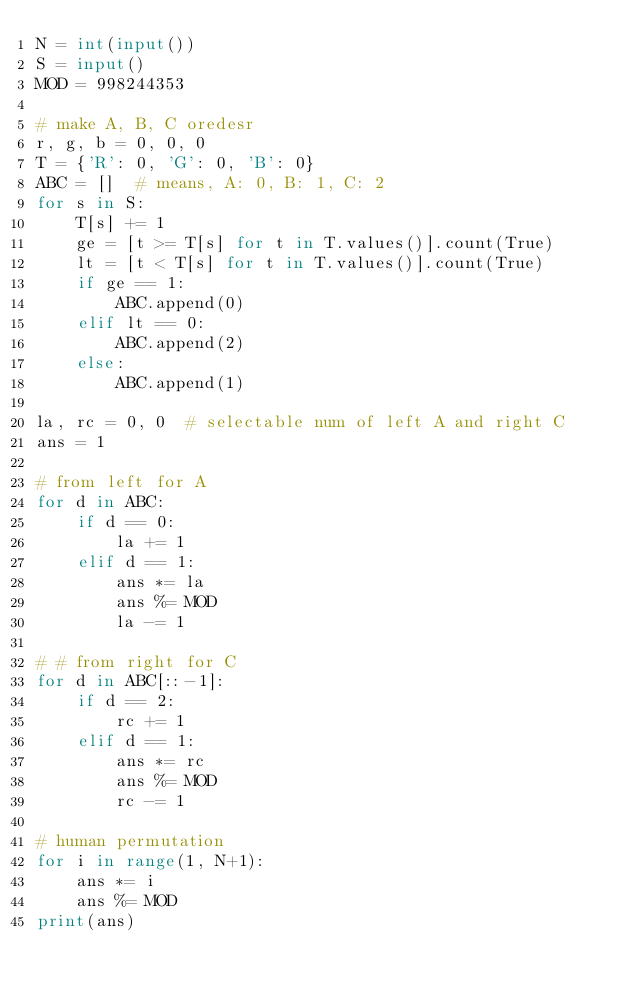Convert code to text. <code><loc_0><loc_0><loc_500><loc_500><_Python_>N = int(input())
S = input()
MOD = 998244353

# make A, B, C oredesr
r, g, b = 0, 0, 0
T = {'R': 0, 'G': 0, 'B': 0}
ABC = []  # means, A: 0, B: 1, C: 2
for s in S:
    T[s] += 1
    ge = [t >= T[s] for t in T.values()].count(True)
    lt = [t < T[s] for t in T.values()].count(True)
    if ge == 1:
        ABC.append(0)
    elif lt == 0:
        ABC.append(2)
    else:
        ABC.append(1)

la, rc = 0, 0  # selectable num of left A and right C
ans = 1

# from left for A
for d in ABC:
    if d == 0:
        la += 1
    elif d == 1:
        ans *= la
        ans %= MOD
        la -= 1

# # from right for C
for d in ABC[::-1]:
    if d == 2:
        rc += 1
    elif d == 1:
        ans *= rc
        ans %= MOD
        rc -= 1

# human permutation
for i in range(1, N+1):
    ans *= i
    ans %= MOD
print(ans)
</code> 